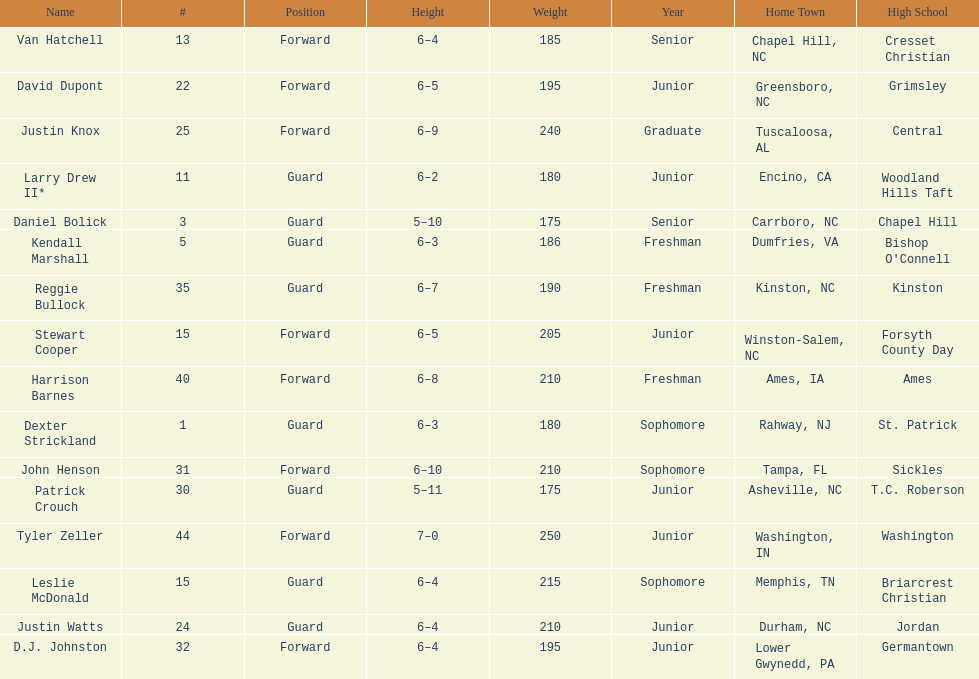Total number of players whose home town was in north carolina (nc) 7. 